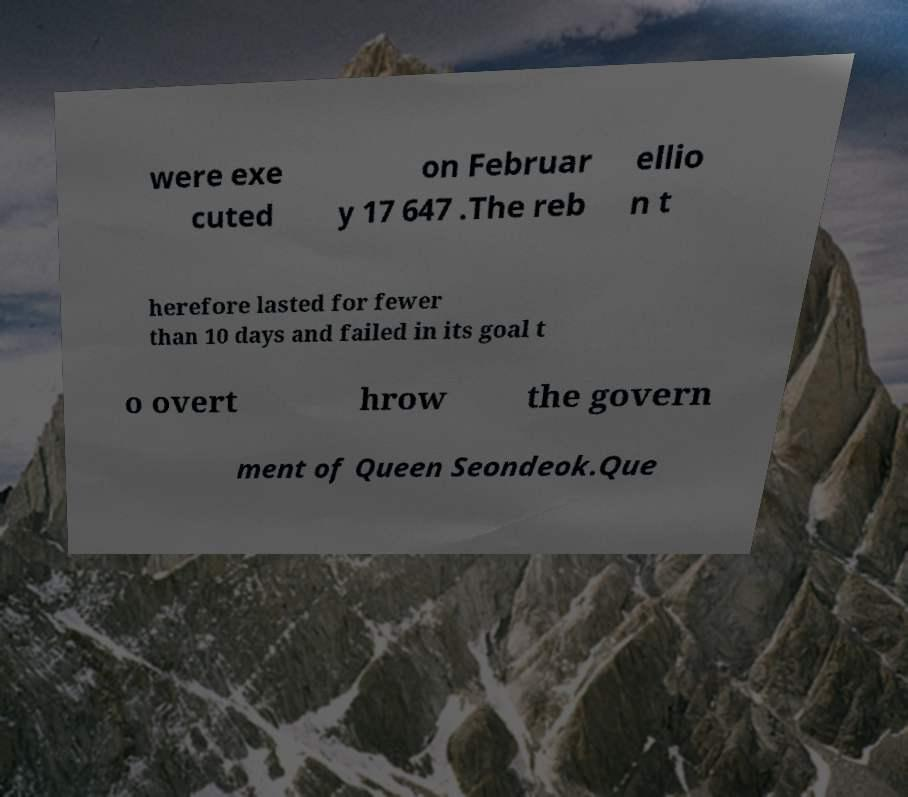Please identify and transcribe the text found in this image. were exe cuted on Februar y 17 647 .The reb ellio n t herefore lasted for fewer than 10 days and failed in its goal t o overt hrow the govern ment of Queen Seondeok.Que 